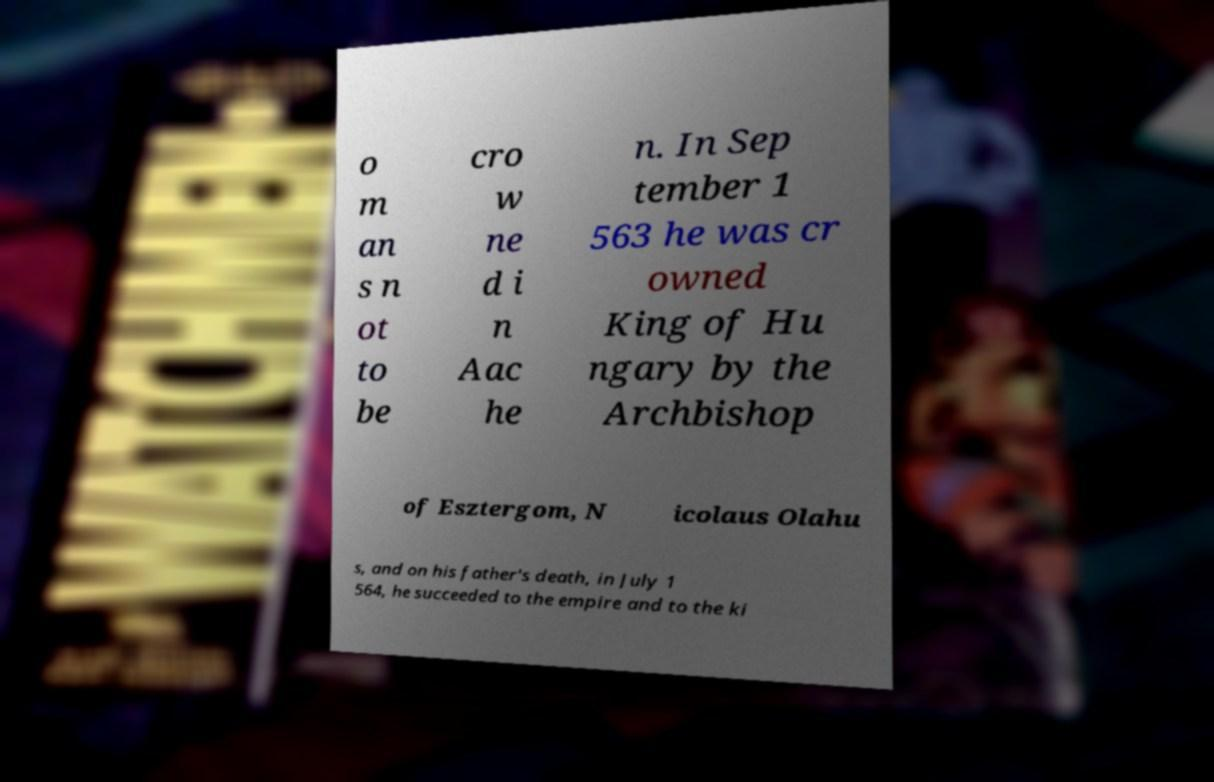Please read and relay the text visible in this image. What does it say? o m an s n ot to be cro w ne d i n Aac he n. In Sep tember 1 563 he was cr owned King of Hu ngary by the Archbishop of Esztergom, N icolaus Olahu s, and on his father's death, in July 1 564, he succeeded to the empire and to the ki 